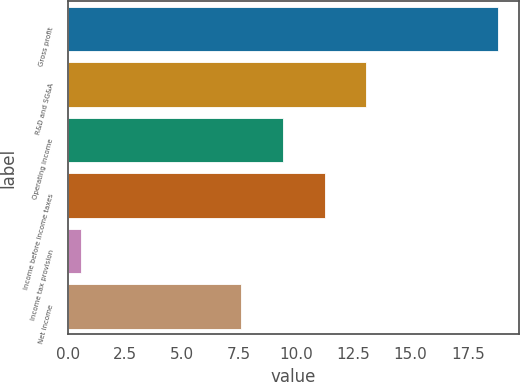Convert chart to OTSL. <chart><loc_0><loc_0><loc_500><loc_500><bar_chart><fcel>Gross profit<fcel>R&D and SG&A<fcel>Operating income<fcel>Income before income taxes<fcel>Income tax provision<fcel>Net income<nl><fcel>18.8<fcel>13.06<fcel>9.42<fcel>11.24<fcel>0.6<fcel>7.6<nl></chart> 